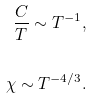<formula> <loc_0><loc_0><loc_500><loc_500>\frac { C } { T } \sim T ^ { - 1 } , \\ \\ \chi \sim T ^ { - 4 / 3 } .</formula> 